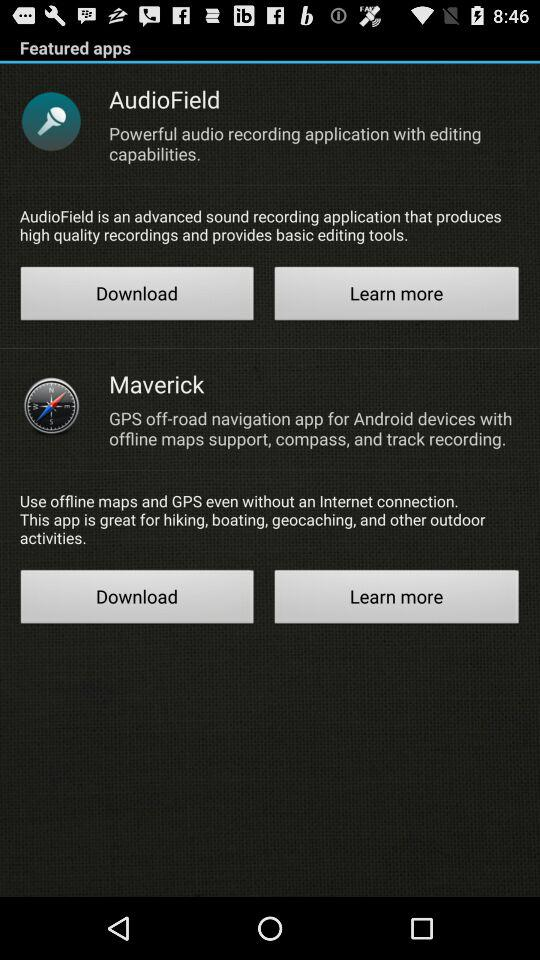What are the featured apps here? The featured apps are : "AudioField" and "Maverick". 